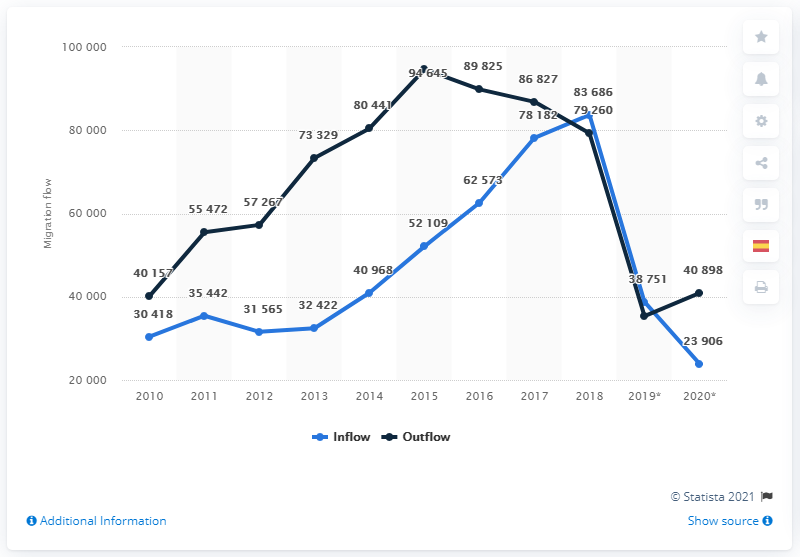In what year did the number of Spaniards returning to Spain begin to fall? According to the data shown in the image, the number of Spaniards returning to Spain began to fall in 2016. This marks a significant change from the previous trend where the number of returns had generally been increasing since 2010. It might be interesting to explore the economic or social events around 2016 that influenced this shift in migration patterns. 